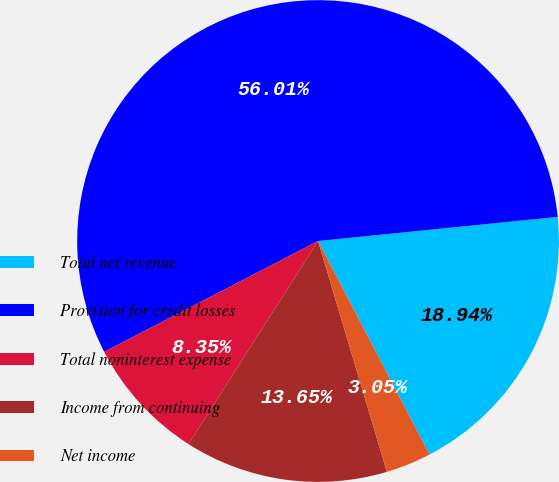Convert chart to OTSL. <chart><loc_0><loc_0><loc_500><loc_500><pie_chart><fcel>Total net revenue<fcel>Provision for credit losses<fcel>Total noninterest expense<fcel>Income from continuing<fcel>Net income<nl><fcel>18.94%<fcel>56.01%<fcel>8.35%<fcel>13.65%<fcel>3.05%<nl></chart> 